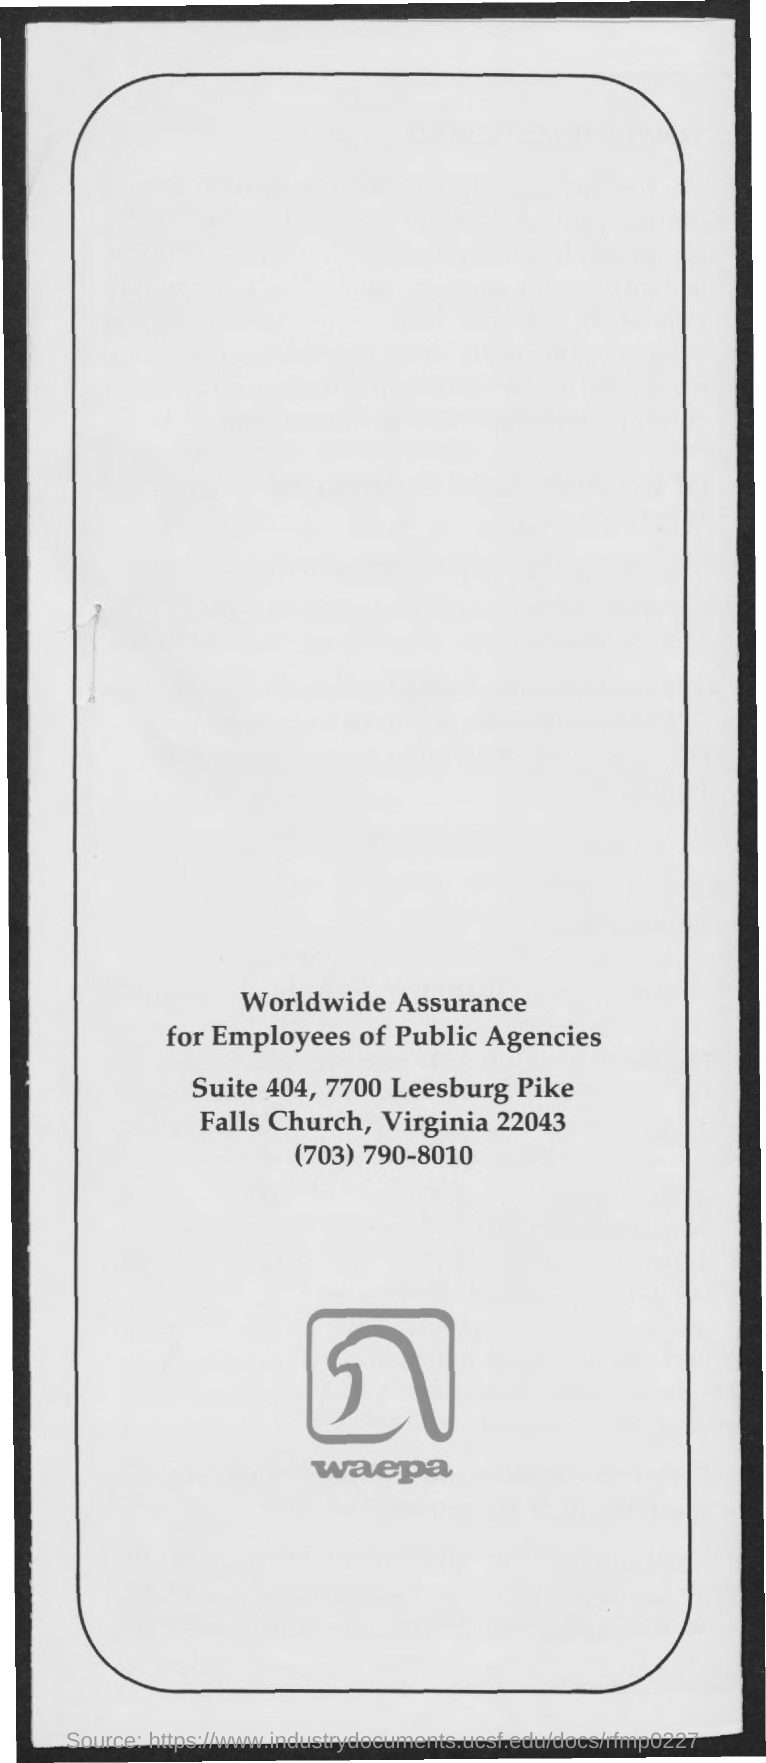Outline some significant characteristics in this image. The text located beneath the logo is 'waepa'. 